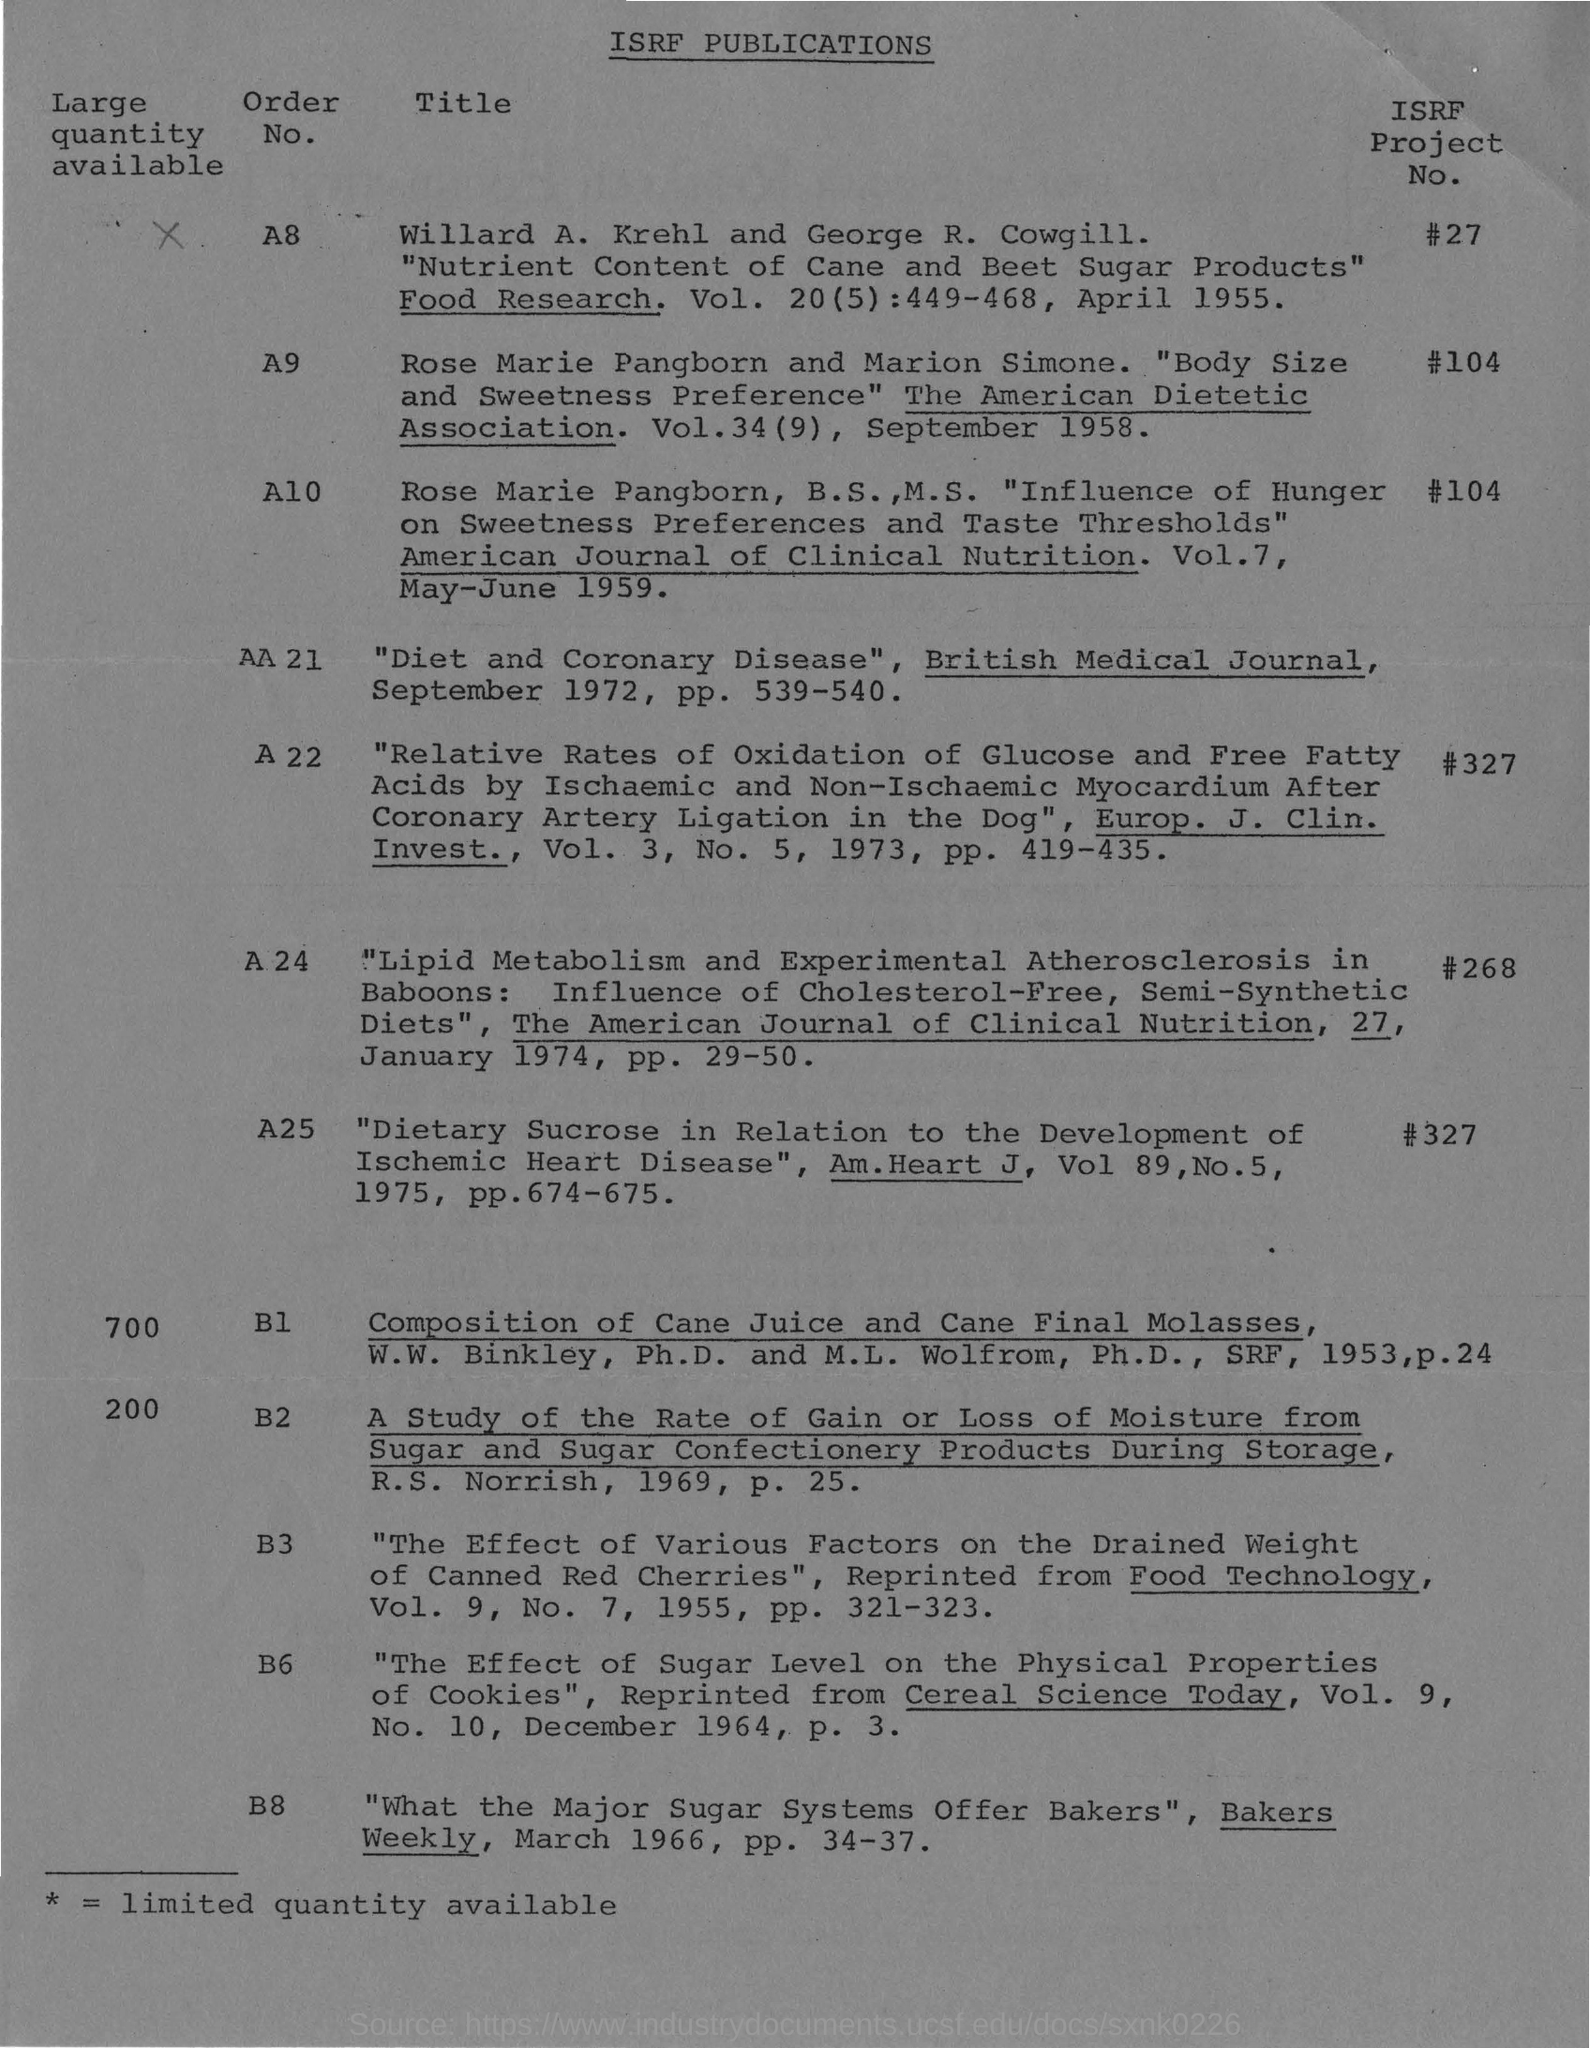What is the "order no." of "isrf project no". #27
Offer a terse response. A8. What is the "order no." of "isrf project no". #104
Ensure brevity in your answer.  A9. What is the "order no." of "isrf project no". #268
Your answer should be compact. A 24. 